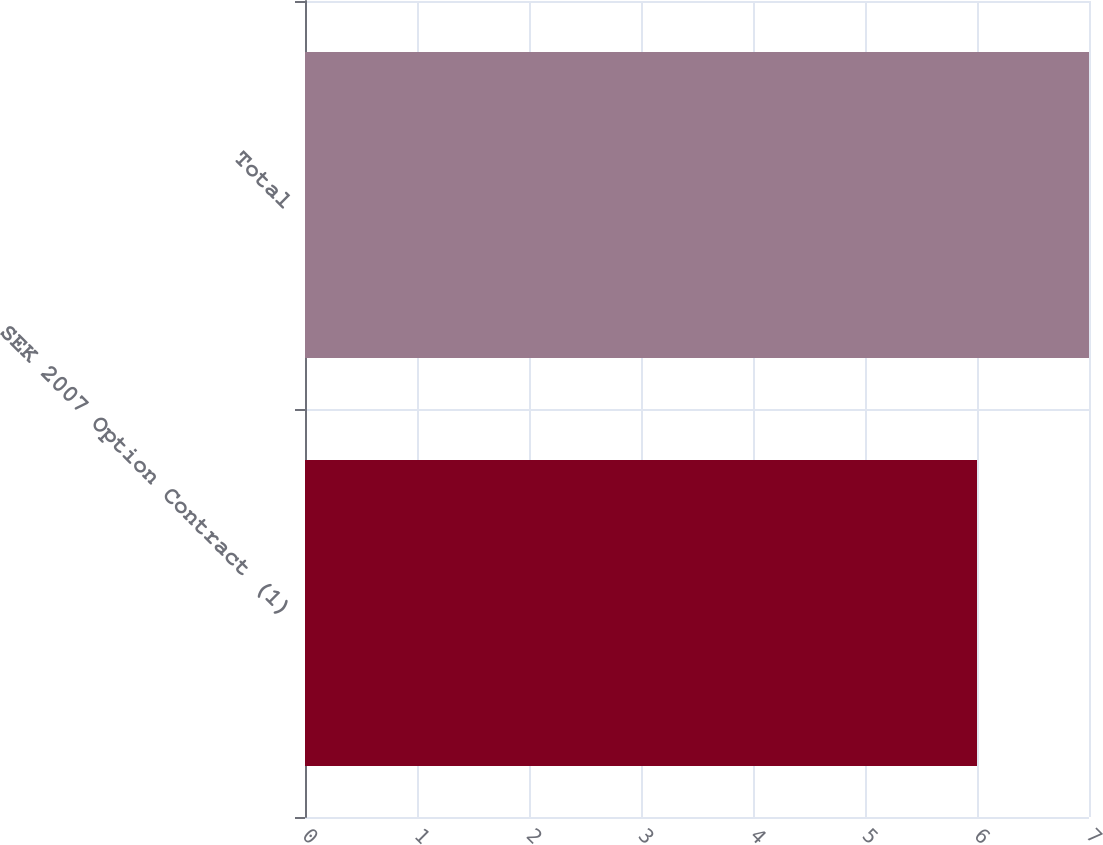Convert chart to OTSL. <chart><loc_0><loc_0><loc_500><loc_500><bar_chart><fcel>SEK 2007 Option Contract (1)<fcel>Total<nl><fcel>6<fcel>7<nl></chart> 